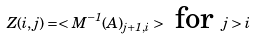<formula> <loc_0><loc_0><loc_500><loc_500>Z ( i , j ) = < M ^ { - 1 } ( A ) _ { j + 1 , i } > \text { for } j > i</formula> 